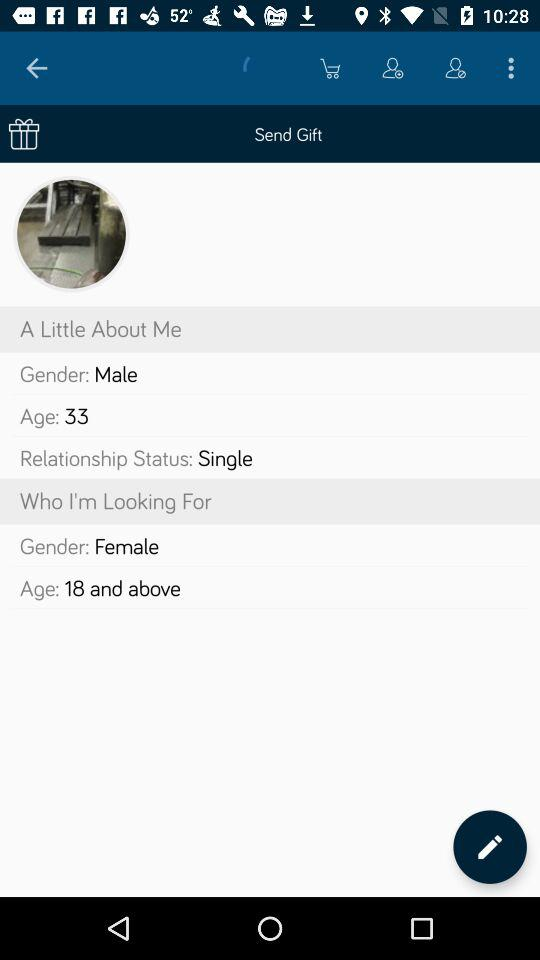How many gifts have been sent?
When the provided information is insufficient, respond with <no answer>. <no answer> 